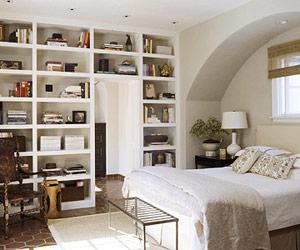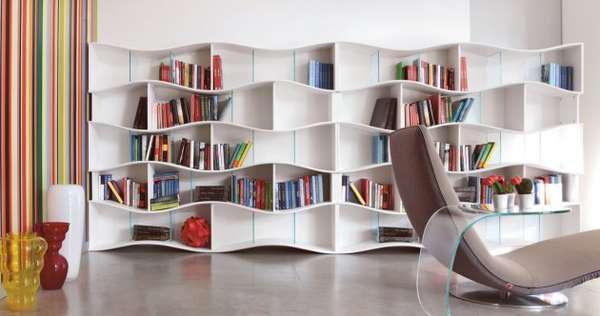The first image is the image on the left, the second image is the image on the right. Analyze the images presented: Is the assertion "The bookshelf in the image on the right frame an arch." valid? Answer yes or no. No. The first image is the image on the left, the second image is the image on the right. Examine the images to the left and right. Is the description "An image shows a bed that extends from a recessed area created by bookshelves that surround it." accurate? Answer yes or no. No. 